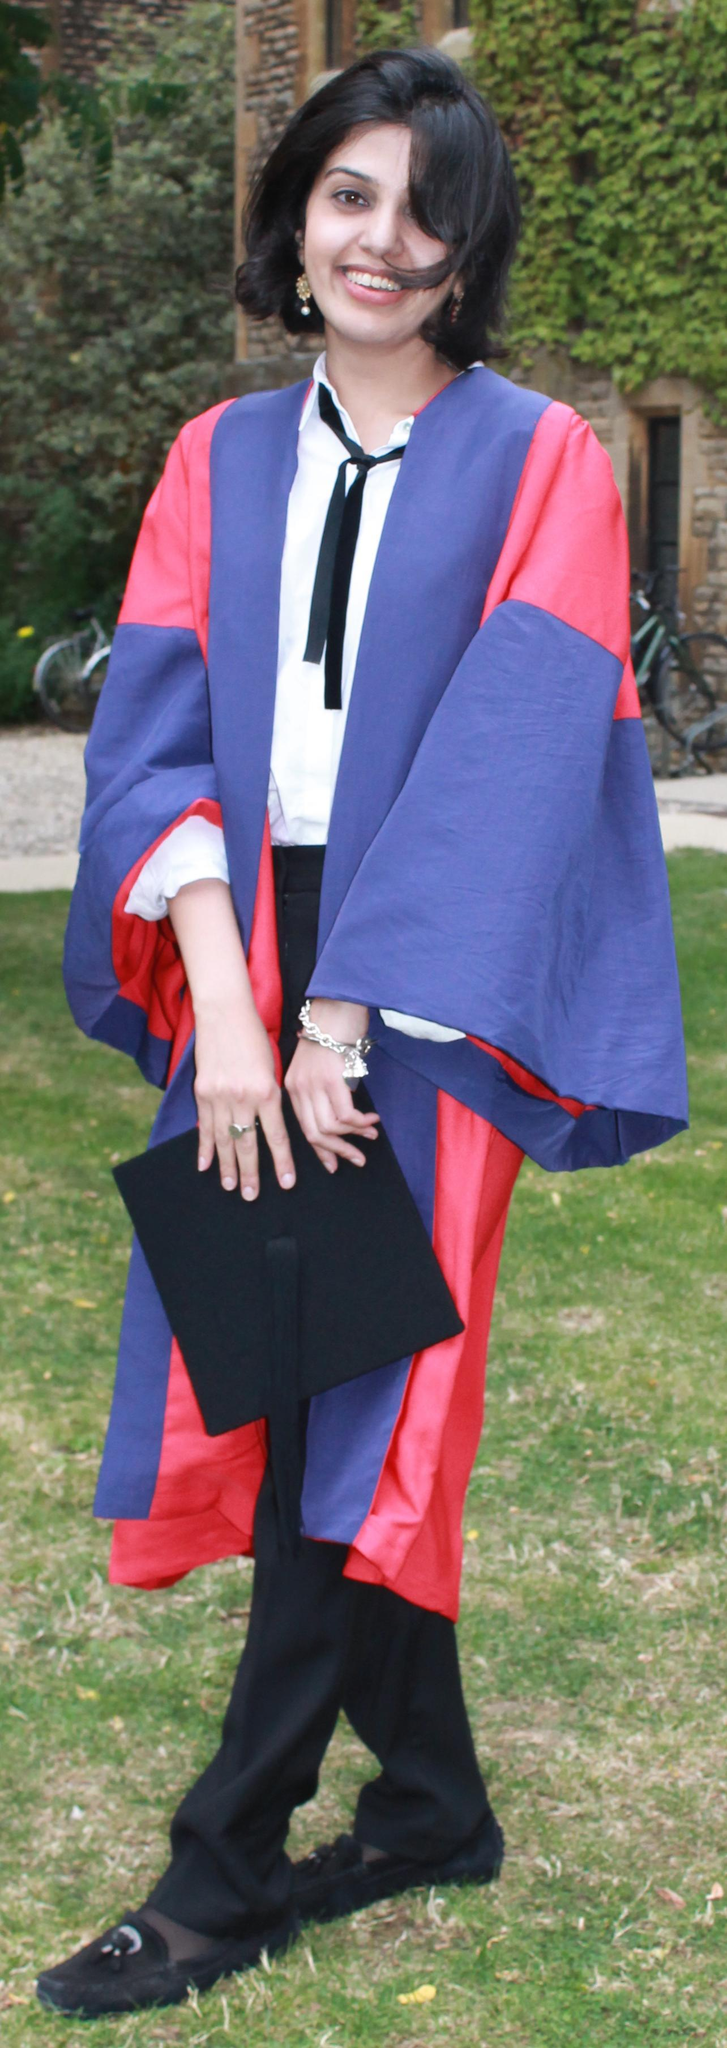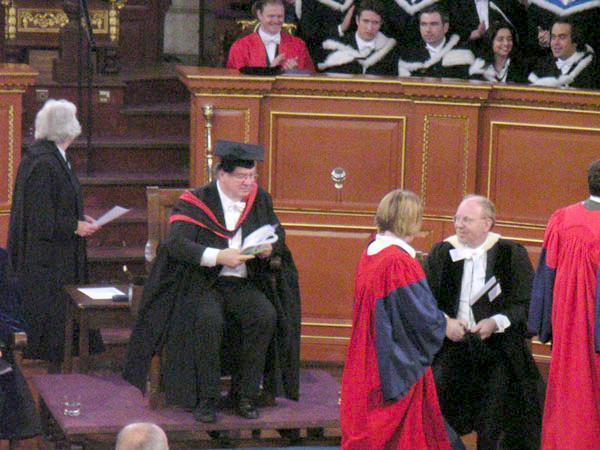The first image is the image on the left, the second image is the image on the right. Analyze the images presented: Is the assertion "Right image shows one male graduate posed in colorful gown on grass." valid? Answer yes or no. No. The first image is the image on the left, the second image is the image on the right. Assess this claim about the two images: "There are no more than 3 graduates pictured.". Correct or not? Answer yes or no. No. 